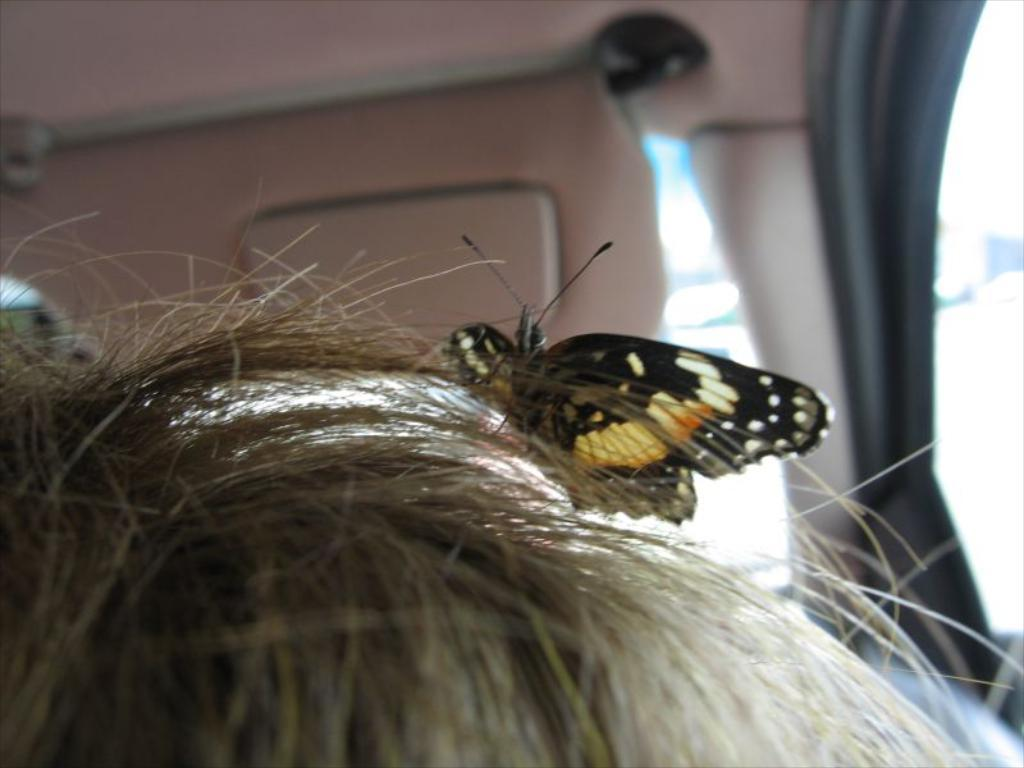What is the main subject in the center of the image? There is a vehicle in the center of the image. Can you describe anything inside the vehicle? There is hair visible in the vehicle. What is on the hair inside the vehicle? There is a butterfly on the hair. What type of faucet can be seen in the vehicle? There is no faucet present in the vehicle; the image only shows hair and a butterfly. 